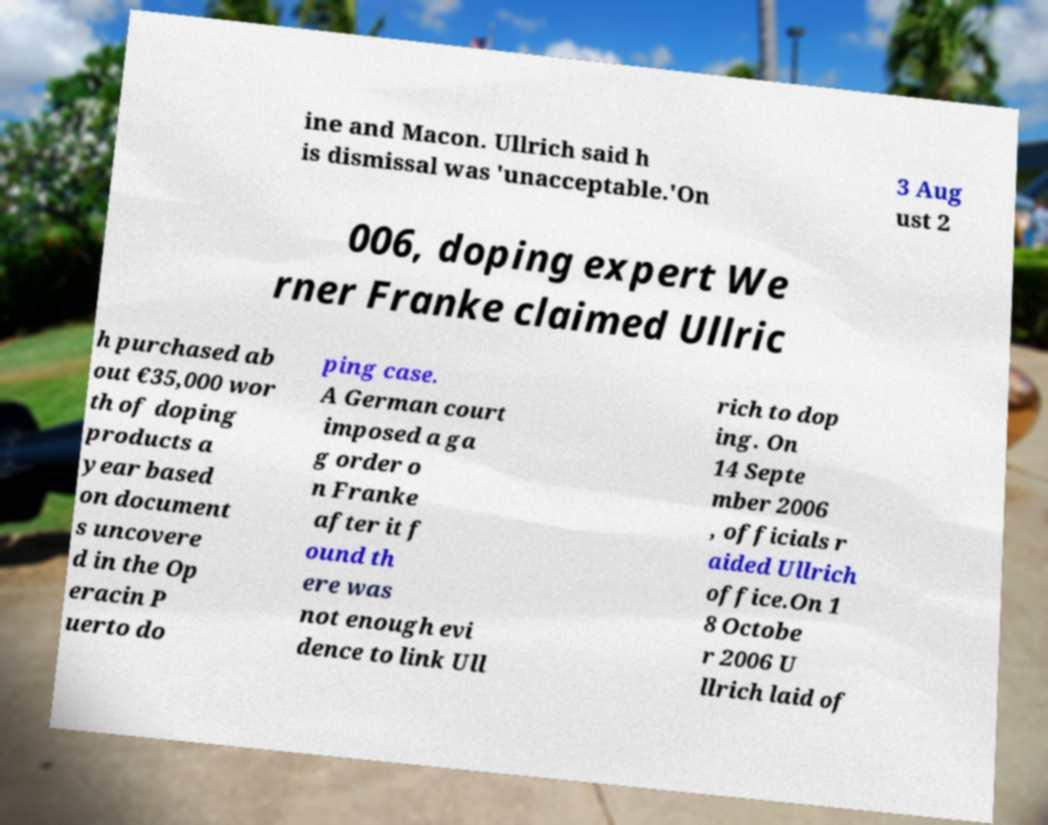Could you assist in decoding the text presented in this image and type it out clearly? ine and Macon. Ullrich said h is dismissal was 'unacceptable.'On 3 Aug ust 2 006, doping expert We rner Franke claimed Ullric h purchased ab out €35,000 wor th of doping products a year based on document s uncovere d in the Op eracin P uerto do ping case. A German court imposed a ga g order o n Franke after it f ound th ere was not enough evi dence to link Ull rich to dop ing. On 14 Septe mber 2006 , officials r aided Ullrich office.On 1 8 Octobe r 2006 U llrich laid of 